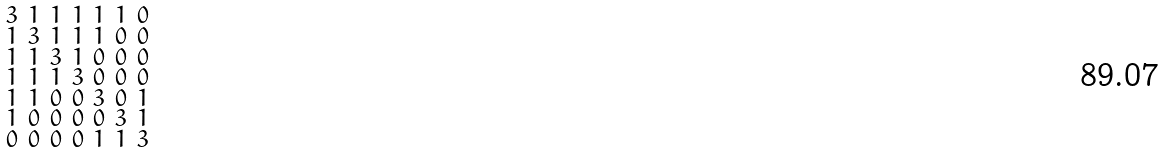<formula> <loc_0><loc_0><loc_500><loc_500>\begin{smallmatrix} 3 & 1 & 1 & 1 & 1 & 1 & 0 \\ 1 & 3 & 1 & 1 & 1 & 0 & 0 \\ 1 & 1 & 3 & 1 & 0 & 0 & 0 \\ 1 & 1 & 1 & 3 & 0 & 0 & 0 \\ 1 & 1 & 0 & 0 & 3 & 0 & 1 \\ 1 & 0 & 0 & 0 & 0 & 3 & 1 \\ 0 & 0 & 0 & 0 & 1 & 1 & 3 \end{smallmatrix}</formula> 